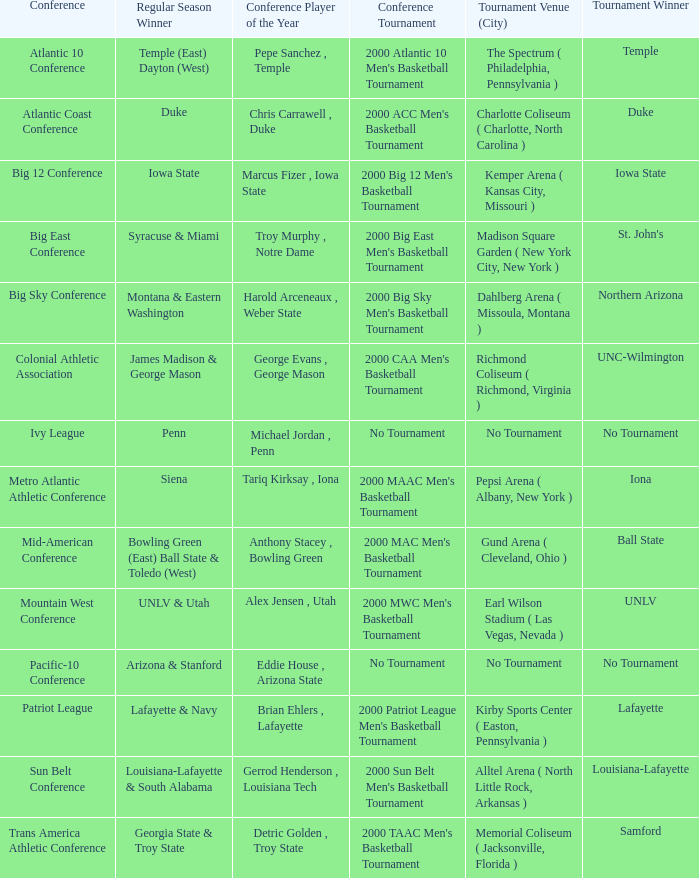What is the venue and city where the 2000 MWC Men's Basketball Tournament? Earl Wilson Stadium ( Las Vegas, Nevada ). 